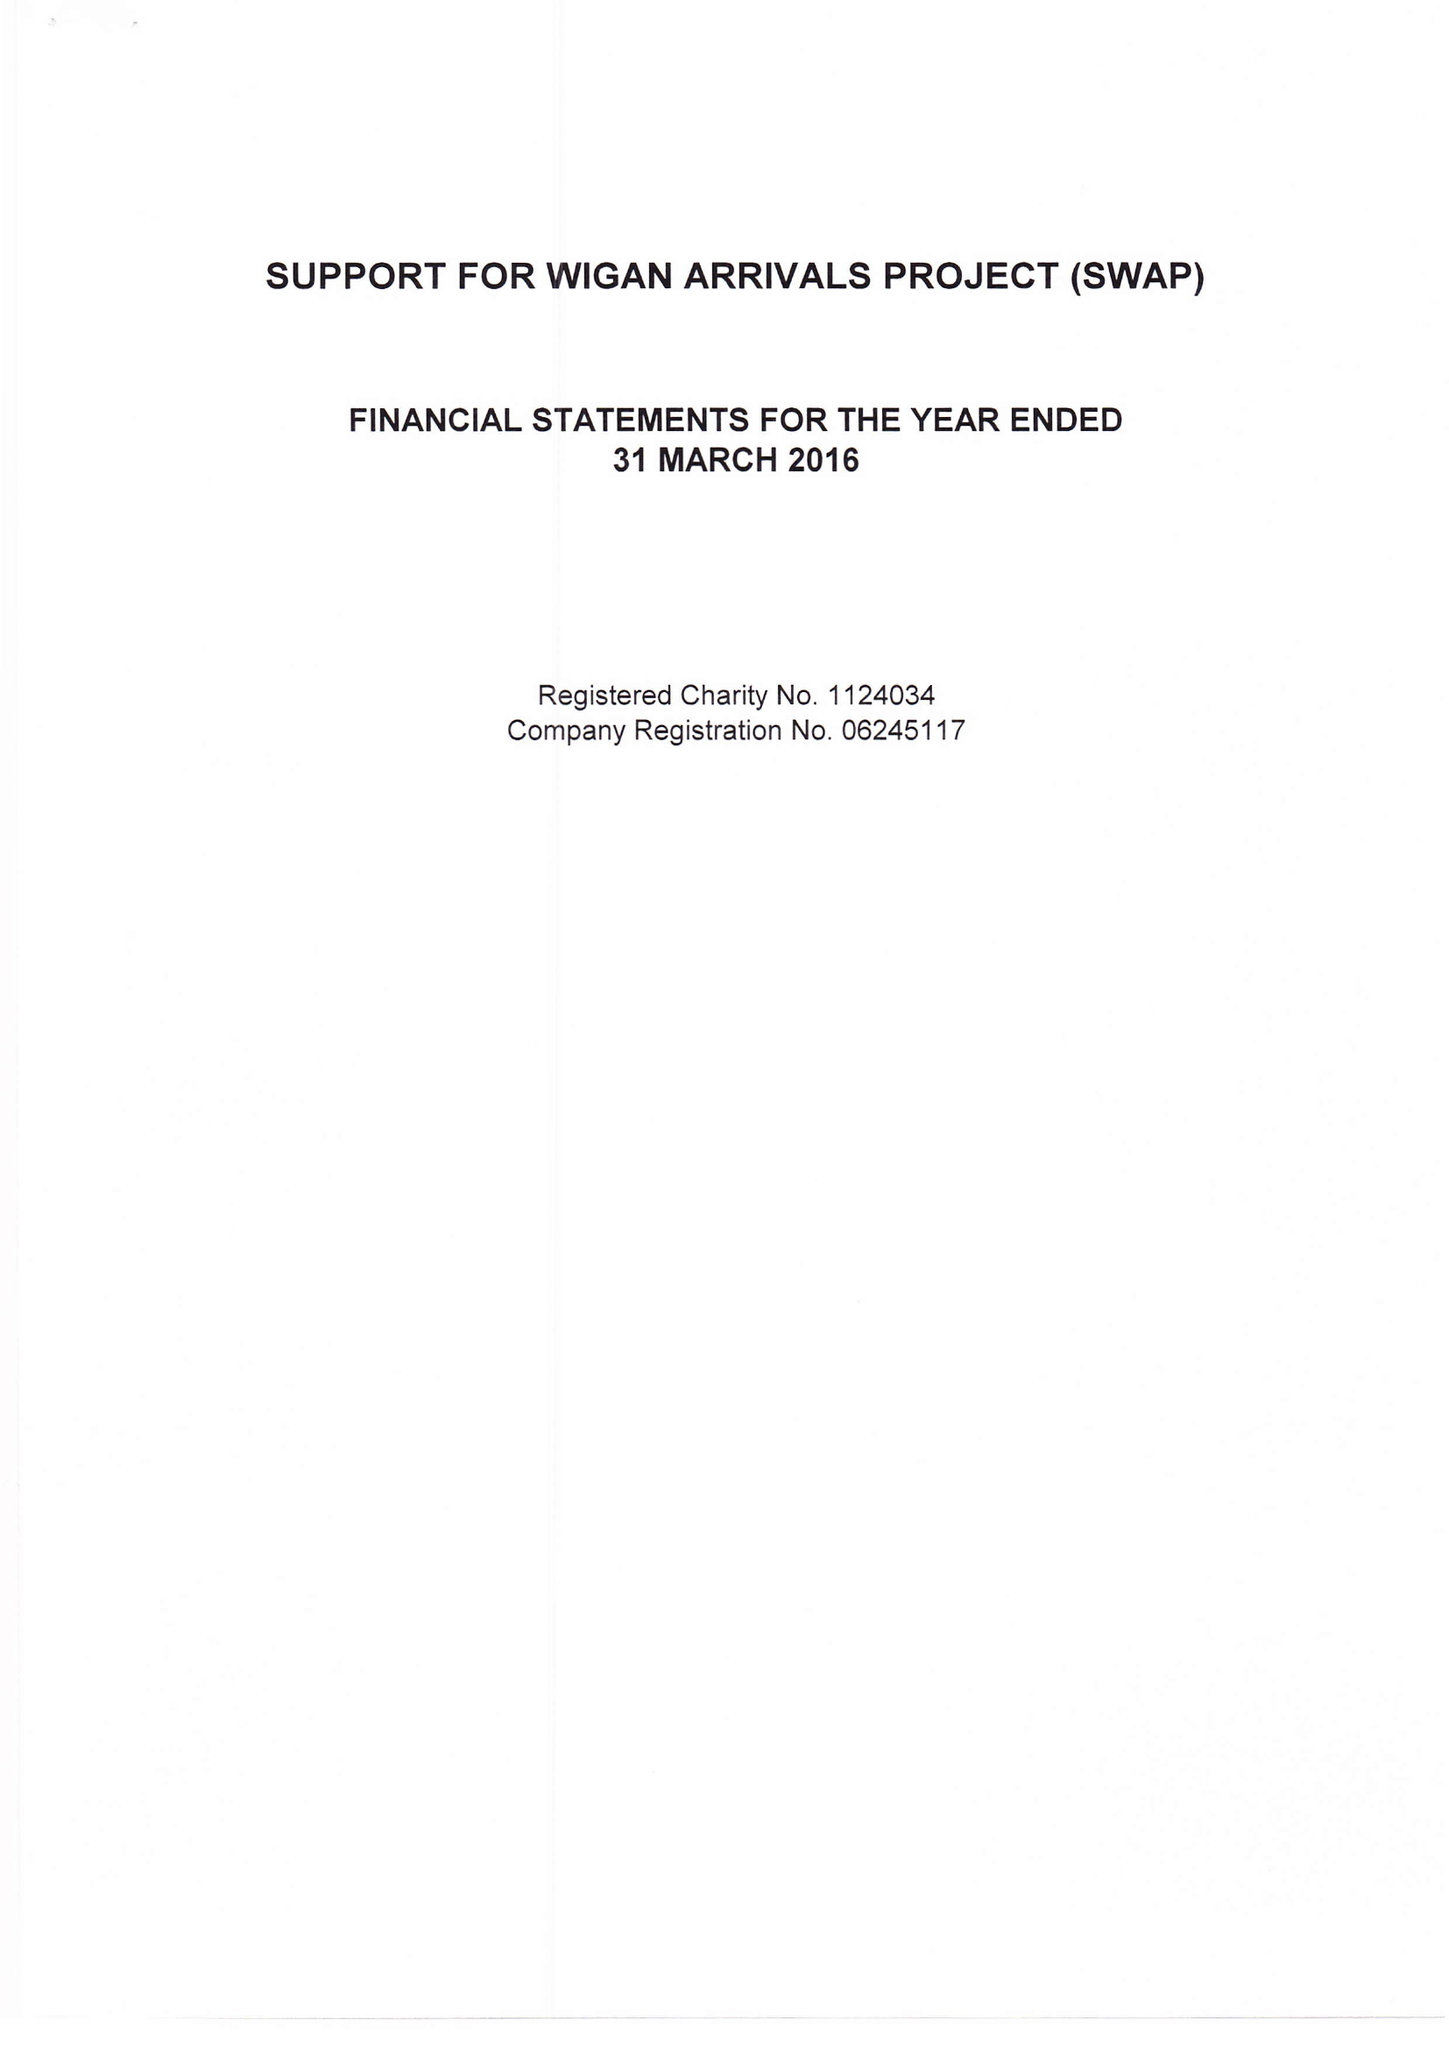What is the value for the income_annually_in_british_pounds?
Answer the question using a single word or phrase. 92180.00 